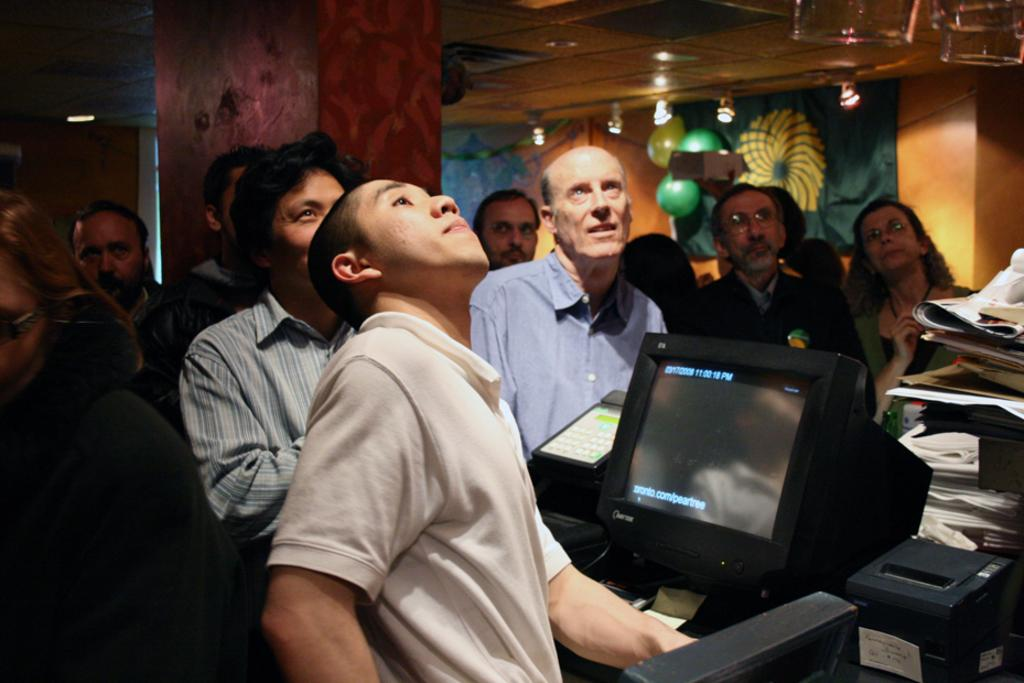What type of electronic device is present in the image? There is a black monitor in the image. How many people can be seen in the image? There are many people in the image. What architectural feature is visible in the image? There is a roof visible in the image. What structural element can be seen in the image? There is a pillar in the image. What type of smell can be detected in the image? There is no information about smells in the image, as it only provides visual details. 